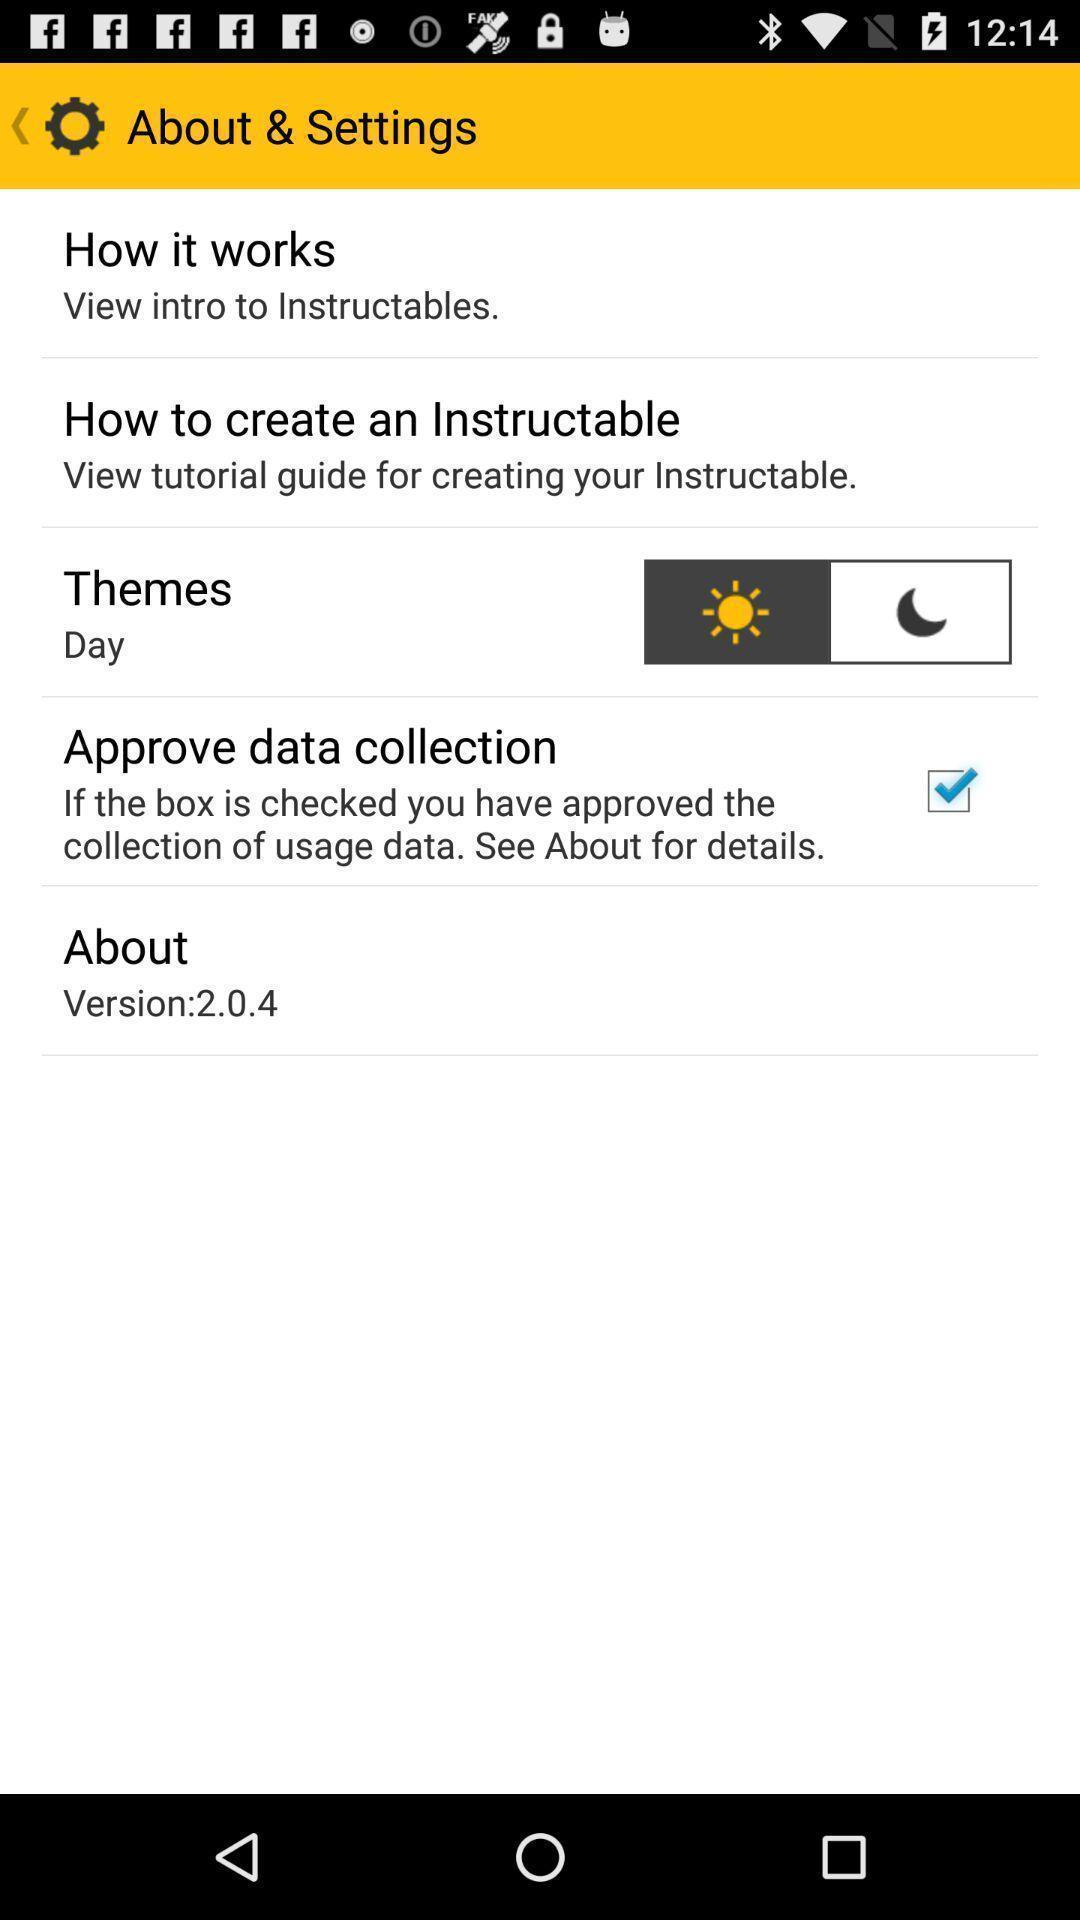Give me a summary of this screen capture. Various setting options. 